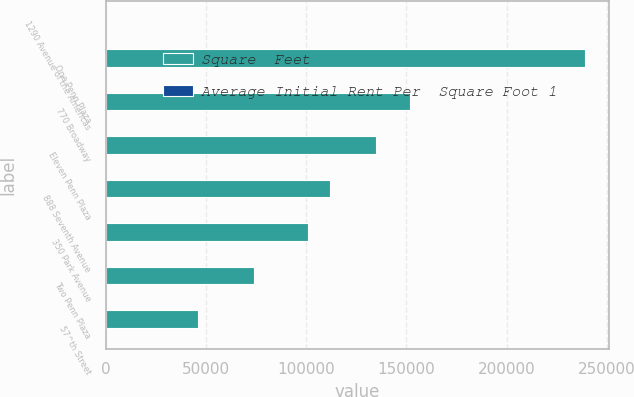Convert chart. <chart><loc_0><loc_0><loc_500><loc_500><stacked_bar_chart><ecel><fcel>1290 Avenue of the Americas<fcel>One Penn Plaza<fcel>770 Broadway<fcel>Eleven Penn Plaza<fcel>888 Seventh Avenue<fcel>350 Park Avenue<fcel>Two Penn Plaza<fcel>57^th Street<nl><fcel>Square  Feet<fcel>107.01<fcel>239000<fcel>152000<fcel>135000<fcel>112000<fcel>101000<fcel>74000<fcel>46000<nl><fcel>Average Initial Rent Per  Square Foot 1<fcel>84.07<fcel>63.87<fcel>69<fcel>56.31<fcel>107.01<fcel>106.42<fcel>59<fcel>46.56<nl></chart> 